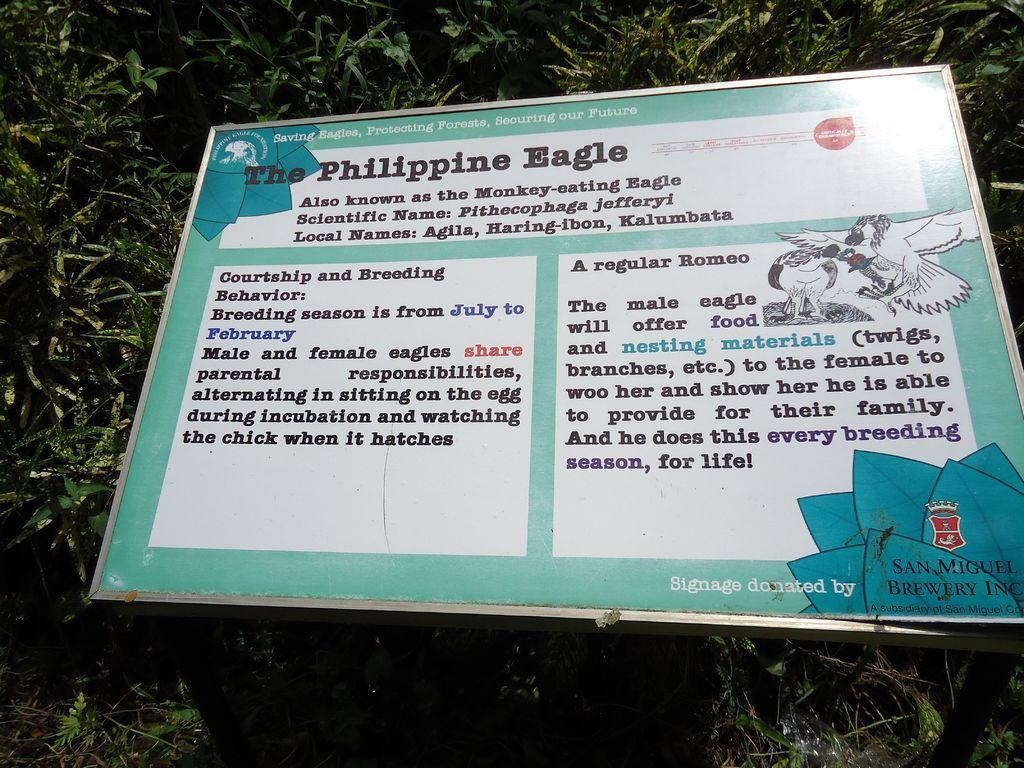Can you describe this image briefly? In this picture I see the plants and on it I see a board on which there is something written and on the right side of the board I see the depiction of birds. 